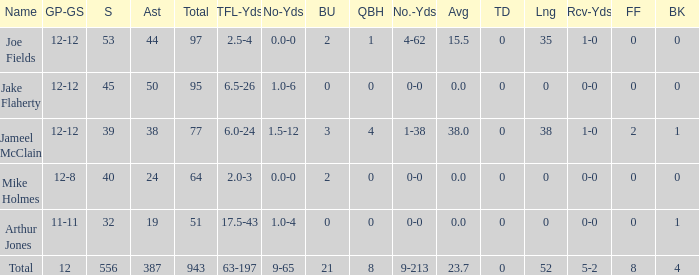How many players named jake flaherty? 1.0. 